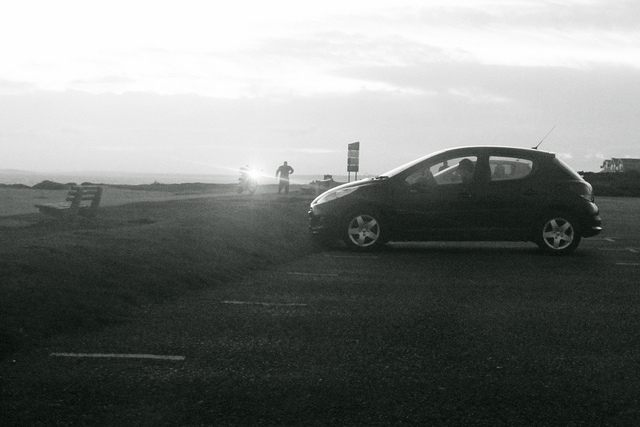<image>How many vehicles are blue? I am not sure how many vehicles are blue. It could be either 1 or none. How many vehicles are blue? I don't know how many vehicles are blue. It can be either 1 or 0. 